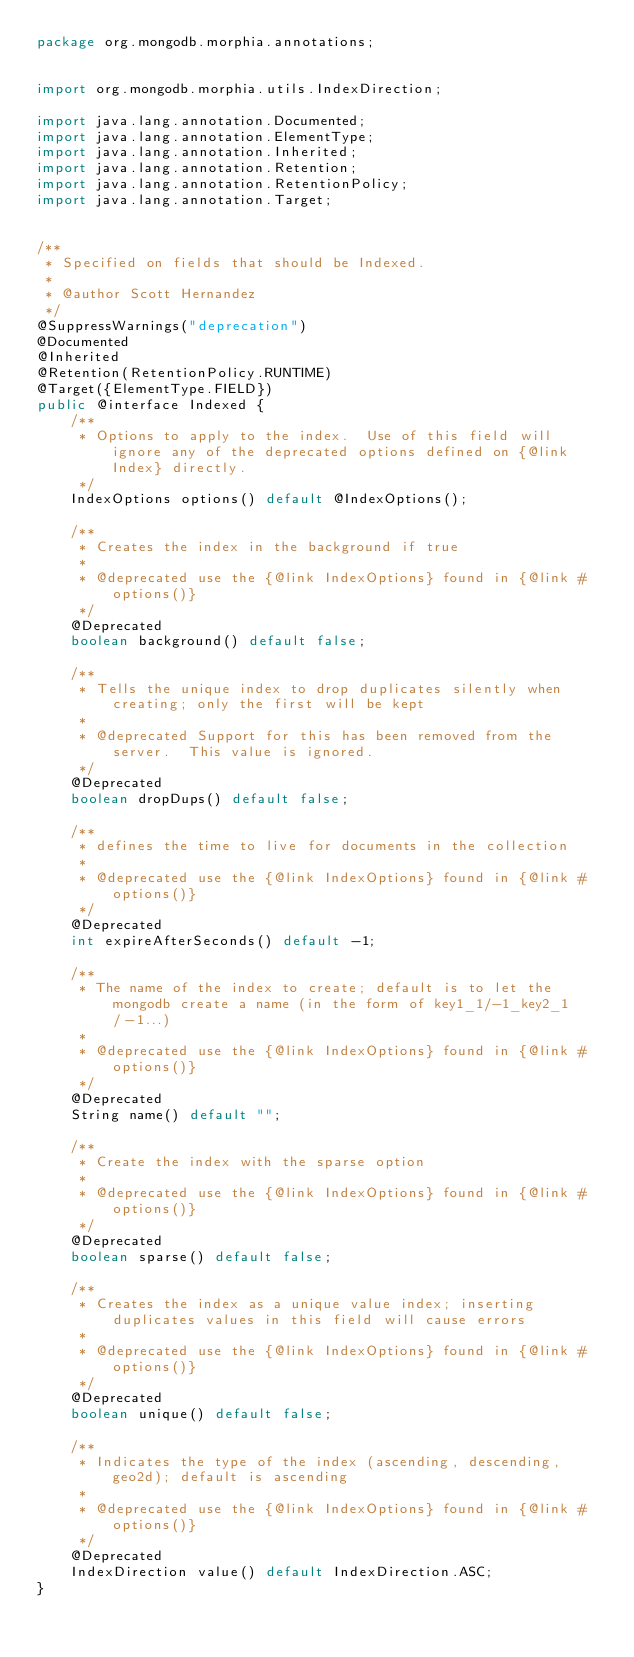Convert code to text. <code><loc_0><loc_0><loc_500><loc_500><_Java_>package org.mongodb.morphia.annotations;


import org.mongodb.morphia.utils.IndexDirection;

import java.lang.annotation.Documented;
import java.lang.annotation.ElementType;
import java.lang.annotation.Inherited;
import java.lang.annotation.Retention;
import java.lang.annotation.RetentionPolicy;
import java.lang.annotation.Target;


/**
 * Specified on fields that should be Indexed.
 *
 * @author Scott Hernandez
 */
@SuppressWarnings("deprecation")
@Documented
@Inherited
@Retention(RetentionPolicy.RUNTIME)
@Target({ElementType.FIELD})
public @interface Indexed {
    /**
     * Options to apply to the index.  Use of this field will ignore any of the deprecated options defined on {@link Index} directly.
     */
    IndexOptions options() default @IndexOptions();

    /**
     * Creates the index in the background if true
     *
     * @deprecated use the {@link IndexOptions} found in {@link #options()}
     */
    @Deprecated
    boolean background() default false;

    /**
     * Tells the unique index to drop duplicates silently when creating; only the first will be kept
     *
     * @deprecated Support for this has been removed from the server.  This value is ignored.
     */
    @Deprecated
    boolean dropDups() default false;

    /**
     * defines the time to live for documents in the collection
     *
     * @deprecated use the {@link IndexOptions} found in {@link #options()}
     */
    @Deprecated
    int expireAfterSeconds() default -1;

    /**
     * The name of the index to create; default is to let the mongodb create a name (in the form of key1_1/-1_key2_1/-1...)
     *
     * @deprecated use the {@link IndexOptions} found in {@link #options()}
     */
    @Deprecated
    String name() default "";

    /**
     * Create the index with the sparse option
     *
     * @deprecated use the {@link IndexOptions} found in {@link #options()}
     */
    @Deprecated
    boolean sparse() default false;

    /**
     * Creates the index as a unique value index; inserting duplicates values in this field will cause errors
     *
     * @deprecated use the {@link IndexOptions} found in {@link #options()}
     */
    @Deprecated
    boolean unique() default false;

    /**
     * Indicates the type of the index (ascending, descending, geo2d); default is ascending
     *
     * @deprecated use the {@link IndexOptions} found in {@link #options()}
     */
    @Deprecated
    IndexDirection value() default IndexDirection.ASC;
}
</code> 